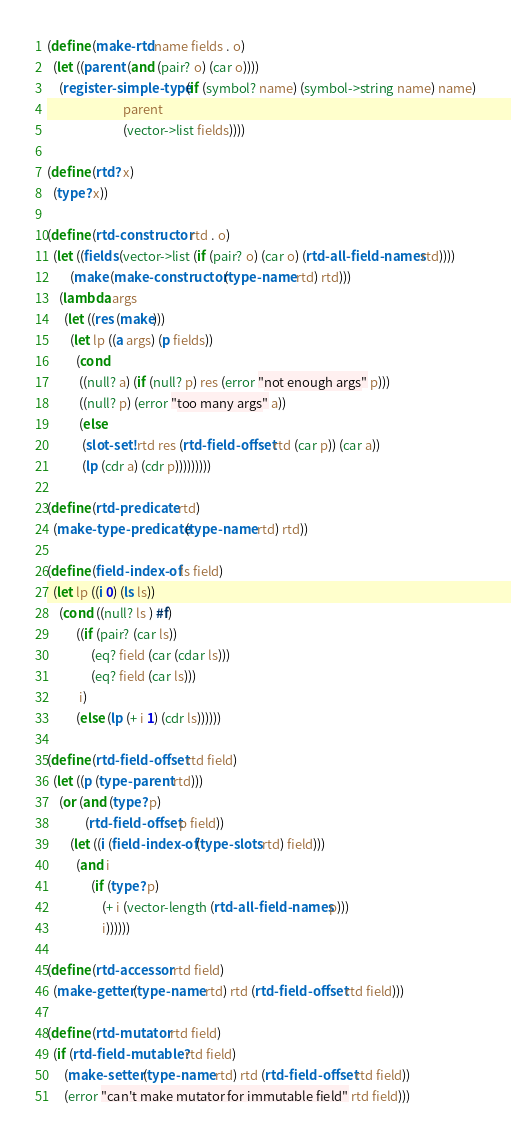<code> <loc_0><loc_0><loc_500><loc_500><_Scheme_>
(define (make-rtd name fields . o)
  (let ((parent (and (pair? o) (car o))))
    (register-simple-type (if (symbol? name) (symbol->string name) name)
                          parent
                          (vector->list fields))))

(define (rtd? x)
  (type? x))

(define (rtd-constructor rtd . o)
  (let ((fields (vector->list (if (pair? o) (car o) (rtd-all-field-names rtd))))
        (make (make-constructor (type-name rtd) rtd)))
    (lambda args
      (let ((res (make)))
        (let lp ((a args) (p fields))
          (cond
           ((null? a) (if (null? p) res (error "not enough args" p)))
           ((null? p) (error "too many args" a))
           (else
            (slot-set! rtd res (rtd-field-offset rtd (car p)) (car a))
            (lp (cdr a) (cdr p)))))))))

(define (rtd-predicate rtd)
  (make-type-predicate (type-name rtd) rtd))

(define (field-index-of ls field)
  (let lp ((i 0) (ls ls))
    (cond ((null? ls ) #f)
          ((if (pair? (car ls))
               (eq? field (car (cdar ls)))
               (eq? field (car ls)))
           i)
          (else (lp (+ i 1) (cdr ls))))))

(define (rtd-field-offset rtd field)
  (let ((p (type-parent rtd)))
    (or (and (type? p)
             (rtd-field-offset p field))
        (let ((i (field-index-of (type-slots rtd) field)))
          (and i
               (if (type? p)
                   (+ i (vector-length (rtd-all-field-names p)))
                   i))))))

(define (rtd-accessor rtd field)
  (make-getter (type-name rtd) rtd (rtd-field-offset rtd field)))

(define (rtd-mutator rtd field)
  (if (rtd-field-mutable? rtd field)
      (make-setter (type-name rtd) rtd (rtd-field-offset rtd field))
      (error "can't make mutator for immutable field" rtd field)))

</code> 